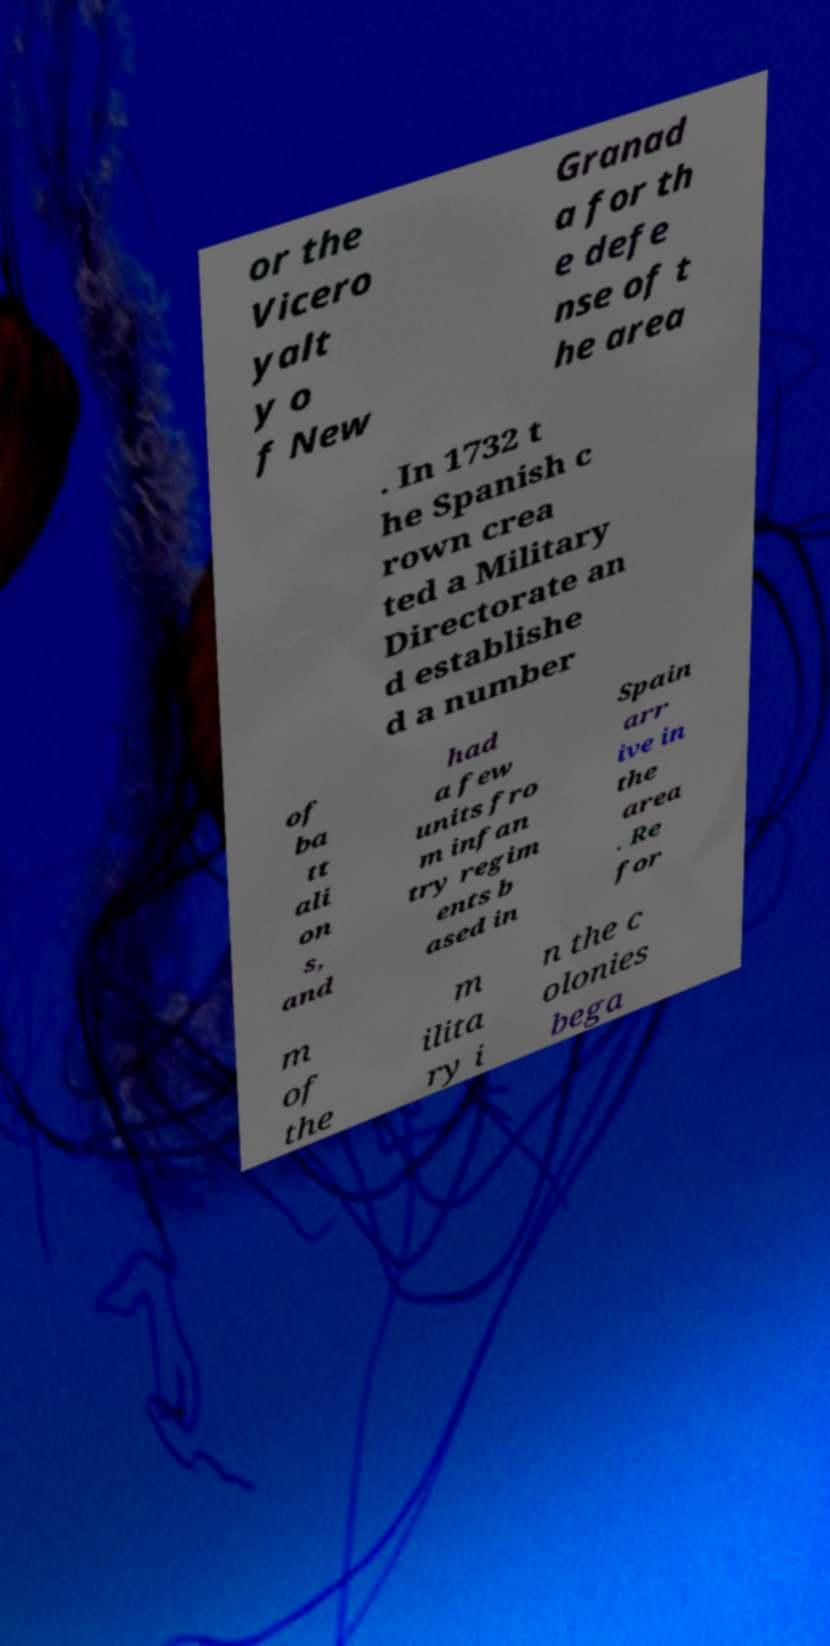Could you assist in decoding the text presented in this image and type it out clearly? or the Vicero yalt y o f New Granad a for th e defe nse of t he area . In 1732 t he Spanish c rown crea ted a Military Directorate an d establishe d a number of ba tt ali on s, and had a few units fro m infan try regim ents b ased in Spain arr ive in the area . Re for m of the m ilita ry i n the c olonies bega 